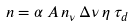Convert formula to latex. <formula><loc_0><loc_0><loc_500><loc_500>n = \alpha \, A \, n _ { \nu } \, \Delta \nu \, \eta \, \tau _ { d }</formula> 